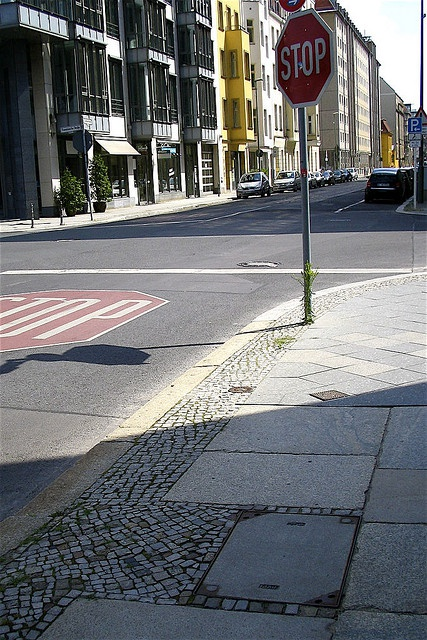Describe the objects in this image and their specific colors. I can see stop sign in gray, lightpink, darkgray, and white tones, stop sign in gray, black, and maroon tones, car in gray, black, darkblue, and blue tones, car in gray, black, lightgray, and darkgray tones, and car in gray, black, white, and darkgray tones in this image. 